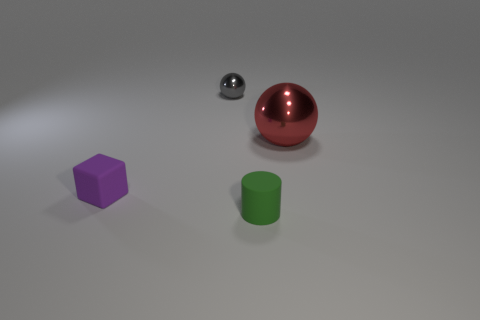Is there a cyan shiny sphere?
Your answer should be very brief. No. Do the green object and the thing that is on the left side of the small metal ball have the same size?
Keep it short and to the point. Yes. Are there any large spheres that are to the right of the tiny thing right of the gray metallic ball?
Keep it short and to the point. Yes. There is a small object that is in front of the gray object and to the right of the small purple thing; what material is it?
Your response must be concise. Rubber. What color is the tiny rubber cube on the left side of the big red metallic sphere that is on the right side of the tiny purple object in front of the tiny metal object?
Provide a succinct answer. Purple. What color is the rubber object that is the same size as the purple matte cube?
Keep it short and to the point. Green. What is the object that is in front of the small matte object on the left side of the gray shiny sphere made of?
Provide a succinct answer. Rubber. How many objects are both on the right side of the purple cube and in front of the gray thing?
Make the answer very short. 2. What number of other objects are there of the same size as the gray metal thing?
Give a very brief answer. 2. Do the shiny thing that is on the left side of the big metal thing and the object in front of the rubber cube have the same shape?
Offer a terse response. No. 